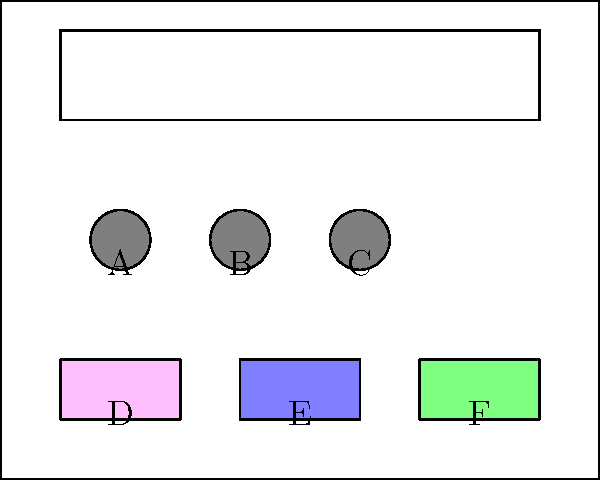As a luxury fashion designer collaborating with a salon owner, you need to arrange the vanity setup for VIP clients. Given the layout above, where A, B, and C represent hair styling tools, and D, E, and F represent makeup products, what is the optimal arrangement to maximize both aesthetic appeal and functionality? Consider the golden ratio (approximately 1.618) in your arrangement. To create an optimal arrangement using the golden ratio and considering both aesthetics and functionality, follow these steps:

1. Identify the golden ratio: The golden ratio is approximately 1.618, often denoted by the Greek letter $\phi$ (phi).

2. Apply the golden ratio to the vanity width:
   Total width = 10 units
   Larger section = 10 / $\phi$ ≈ 6.18 units
   Smaller section = 10 - 6.18 ≈ 3.82 units

3. Arrange hair styling tools (A, B, C):
   Place these tools in the larger section (6.18 units) of the vanity.
   Divide this section into three equal parts: 6.18 / 3 ≈ 2.06 units each.
   Position A at x ≈ 2.06, B at x ≈ 4.12, and C at x ≈ 6.18.

4. Arrange makeup products (D, E, F):
   Place these products in the smaller section (3.82 units) of the vanity.
   Divide this section into three equal parts: 3.82 / 3 ≈ 1.27 units each.
   Position D at x ≈ 7.27, E at x ≈ 8.54, and F at x ≈ 9.81.

5. Consider functionality:
   Hair styling tools (A, B, C) are placed closer to the mirror for easy access during styling.
   Makeup products (D, E, F) are arranged in order of use: primer (D), foundation (E), and finishing products (F).

6. Ensure aesthetic appeal:
   The arrangement follows the golden ratio, creating a visually pleasing composition.
   The symmetrical placement of items on either side of the vanity creates balance.

This arrangement maximizes both aesthetic appeal by utilizing the golden ratio and functionality by considering the practical use of each item.
Answer: A-B-C | D-E-F 